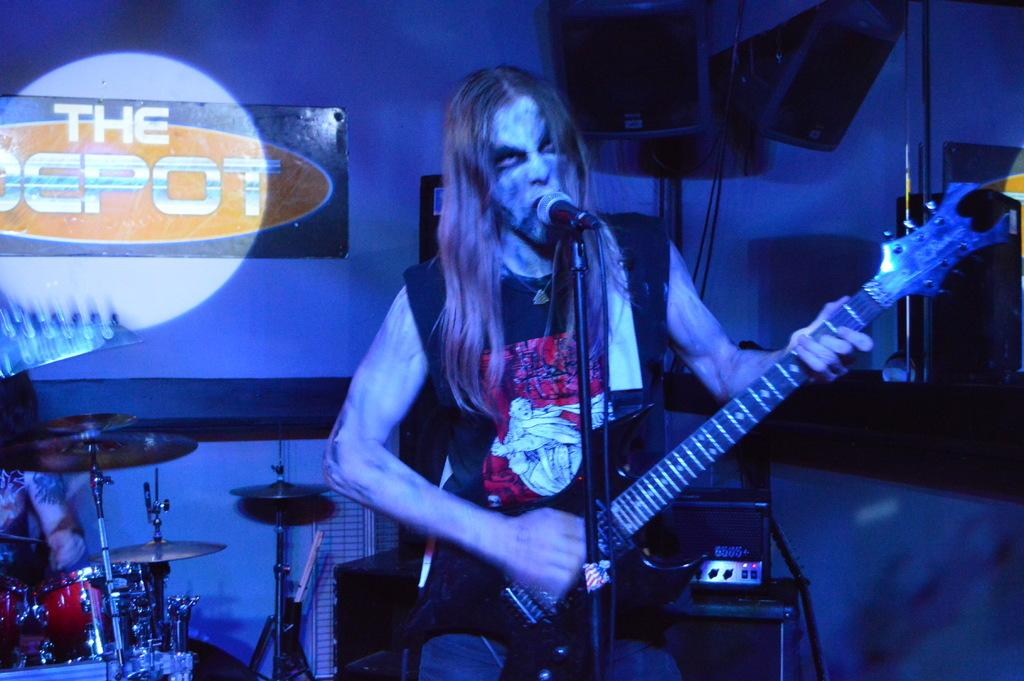Who is the main subject in the image? There is a man in the image. What is the man doing in the image? The man is singing a song. What instrument is the man holding in the image? The man is holding a guitar in his hand. What other musical instrument can be seen in the image? There are musical drums on the left side of the image. How many women are present in the image? There are no women present in the image; it features a man singing and playing a guitar. What color is the paint on the musical drums in the image? There is no paint mentioned or visible on the musical drums in the image. 